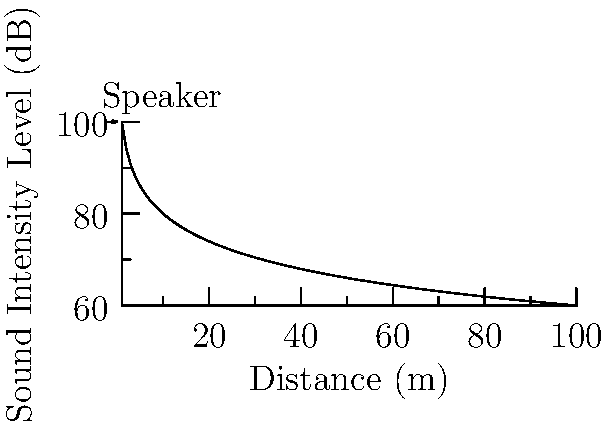During a promotional event for your insurance agency, you're using a speaker system with an initial sound intensity level of 100 dB at 1 meter. To ensure compliance with local noise regulations, you need to determine the sound intensity level at 50 meters from the speaker. Using the inverse square law for sound intensity, calculate the sound intensity level at 50 meters from the speaker. To solve this problem, we'll use the inverse square law for sound intensity and the formula for sound intensity level (SIL).

Step 1: Recall the formula for sound intensity level (SIL):
$$ SIL = 10 \log_{10} \left(\frac{I}{I_0}\right) $$
Where $I$ is the sound intensity and $I_0$ is the reference intensity.

Step 2: The inverse square law states that intensity is inversely proportional to the square of the distance:
$$ I_2 = I_1 \left(\frac{r_1}{r_2}\right)^2 $$

Step 3: We don't know the actual intensities, but we can use the ratio in the SIL formula:
$$ SIL_2 = SIL_1 + 10 \log_{10} \left(\frac{I_2}{I_1}\right) $$

Step 4: Substitute the inverse square law ratio:
$$ SIL_2 = SIL_1 + 10 \log_{10} \left(\frac{r_1}{r_2}\right)^2 $$

Step 5: Plug in the values:
$SIL_1 = 100$ dB, $r_1 = 1$ m, $r_2 = 50$ m

$$ SIL_2 = 100 + 10 \log_{10} \left(\frac{1}{50}\right)^2 $$

Step 6: Simplify:
$$ SIL_2 = 100 + 10 \log_{10} \left(\frac{1}{2500}\right) $$
$$ SIL_2 = 100 - 10 \log_{10} (2500) $$
$$ SIL_2 = 100 - 10 (3.3979) $$
$$ SIL_2 = 100 - 33.979 $$
$$ SIL_2 \approx 66.02 \text{ dB} $$

Therefore, the sound intensity level at 50 meters from the speaker is approximately 66.02 dB.
Answer: 66.02 dB 